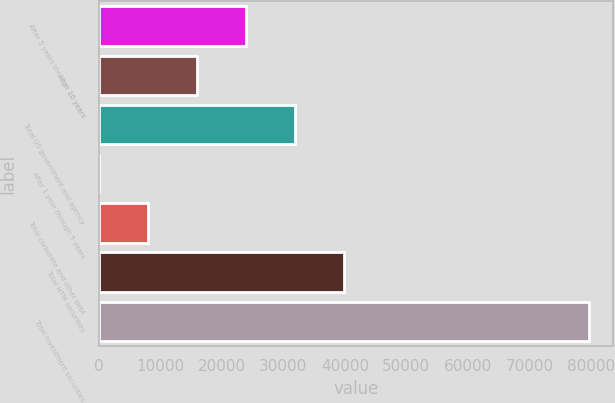Convert chart to OTSL. <chart><loc_0><loc_0><loc_500><loc_500><bar_chart><fcel>After 5 years through 10 years<fcel>After 10 years<fcel>Total US government and agency<fcel>After 1 year through 5 years<fcel>Total corporate and other debt<fcel>Total HTM securities<fcel>Total investment securities<nl><fcel>23968.4<fcel>16010.6<fcel>31926.2<fcel>95<fcel>8052.8<fcel>39884<fcel>79673<nl></chart> 